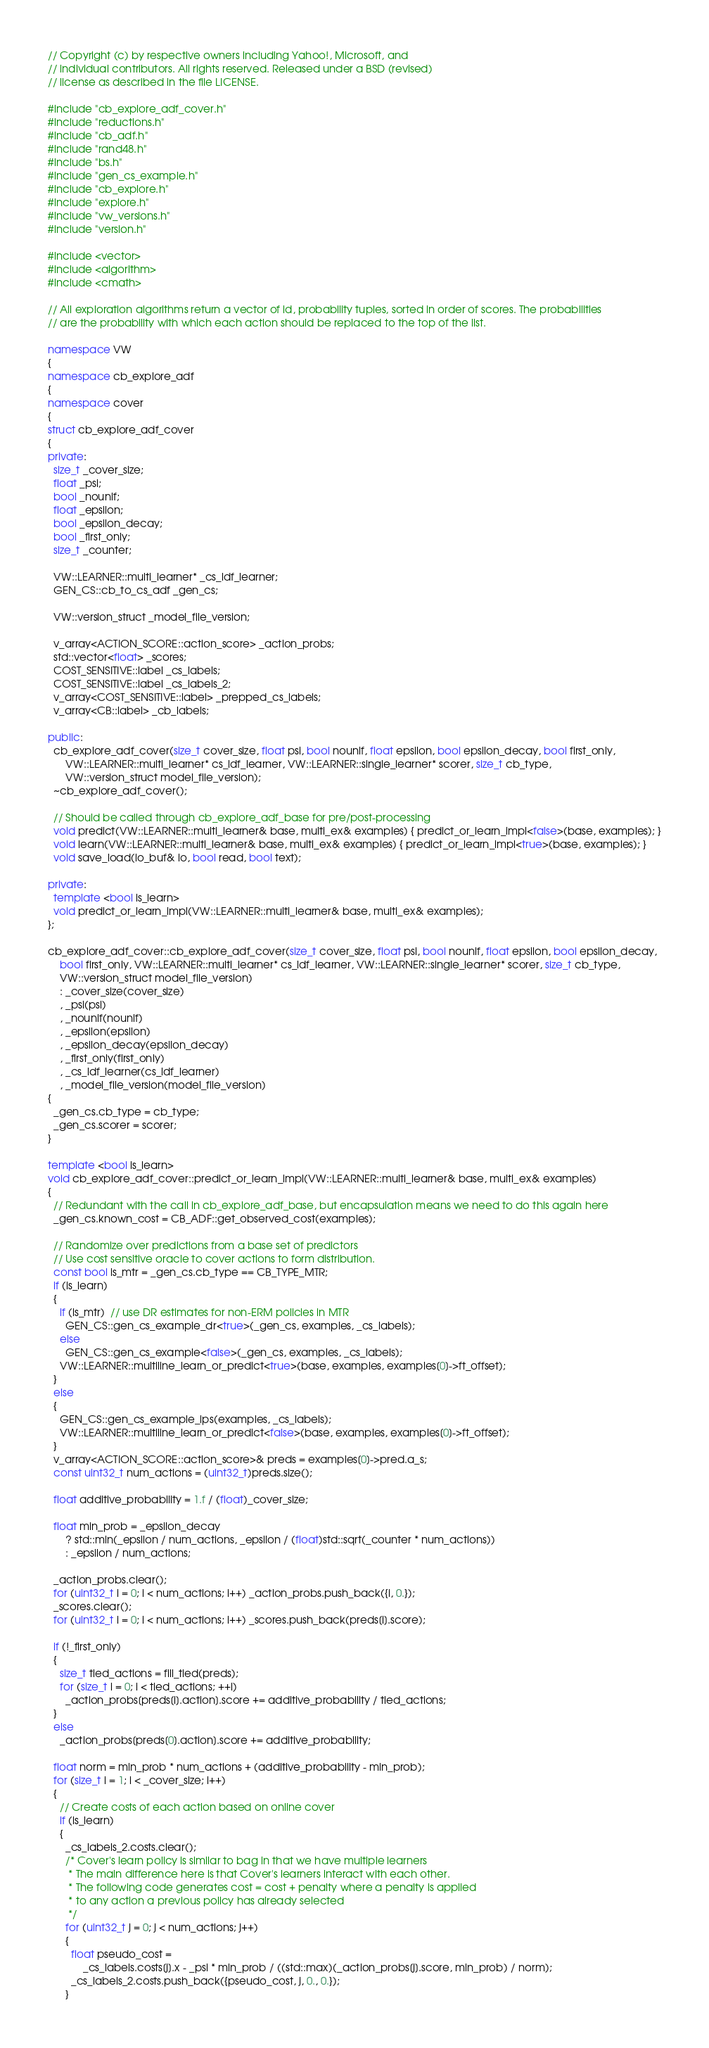Convert code to text. <code><loc_0><loc_0><loc_500><loc_500><_C++_>// Copyright (c) by respective owners including Yahoo!, Microsoft, and
// individual contributors. All rights reserved. Released under a BSD (revised)
// license as described in the file LICENSE.

#include "cb_explore_adf_cover.h"
#include "reductions.h"
#include "cb_adf.h"
#include "rand48.h"
#include "bs.h"
#include "gen_cs_example.h"
#include "cb_explore.h"
#include "explore.h"
#include "vw_versions.h"
#include "version.h"

#include <vector>
#include <algorithm>
#include <cmath>

// All exploration algorithms return a vector of id, probability tuples, sorted in order of scores. The probabilities
// are the probability with which each action should be replaced to the top of the list.

namespace VW
{
namespace cb_explore_adf
{
namespace cover
{
struct cb_explore_adf_cover
{
private:
  size_t _cover_size;
  float _psi;
  bool _nounif;
  float _epsilon;
  bool _epsilon_decay;
  bool _first_only;
  size_t _counter;

  VW::LEARNER::multi_learner* _cs_ldf_learner;
  GEN_CS::cb_to_cs_adf _gen_cs;

  VW::version_struct _model_file_version;

  v_array<ACTION_SCORE::action_score> _action_probs;
  std::vector<float> _scores;
  COST_SENSITIVE::label _cs_labels;
  COST_SENSITIVE::label _cs_labels_2;
  v_array<COST_SENSITIVE::label> _prepped_cs_labels;
  v_array<CB::label> _cb_labels;

public:
  cb_explore_adf_cover(size_t cover_size, float psi, bool nounif, float epsilon, bool epsilon_decay, bool first_only,
      VW::LEARNER::multi_learner* cs_ldf_learner, VW::LEARNER::single_learner* scorer, size_t cb_type,
      VW::version_struct model_file_version);
  ~cb_explore_adf_cover();

  // Should be called through cb_explore_adf_base for pre/post-processing
  void predict(VW::LEARNER::multi_learner& base, multi_ex& examples) { predict_or_learn_impl<false>(base, examples); }
  void learn(VW::LEARNER::multi_learner& base, multi_ex& examples) { predict_or_learn_impl<true>(base, examples); }
  void save_load(io_buf& io, bool read, bool text);

private:
  template <bool is_learn>
  void predict_or_learn_impl(VW::LEARNER::multi_learner& base, multi_ex& examples);
};

cb_explore_adf_cover::cb_explore_adf_cover(size_t cover_size, float psi, bool nounif, float epsilon, bool epsilon_decay,
    bool first_only, VW::LEARNER::multi_learner* cs_ldf_learner, VW::LEARNER::single_learner* scorer, size_t cb_type,
    VW::version_struct model_file_version)
    : _cover_size(cover_size)
    , _psi(psi)
    , _nounif(nounif)
    , _epsilon(epsilon)
    , _epsilon_decay(epsilon_decay)
    , _first_only(first_only)
    , _cs_ldf_learner(cs_ldf_learner)
    , _model_file_version(model_file_version)
{
  _gen_cs.cb_type = cb_type;
  _gen_cs.scorer = scorer;
}

template <bool is_learn>
void cb_explore_adf_cover::predict_or_learn_impl(VW::LEARNER::multi_learner& base, multi_ex& examples)
{
  // Redundant with the call in cb_explore_adf_base, but encapsulation means we need to do this again here
  _gen_cs.known_cost = CB_ADF::get_observed_cost(examples);

  // Randomize over predictions from a base set of predictors
  // Use cost sensitive oracle to cover actions to form distribution.
  const bool is_mtr = _gen_cs.cb_type == CB_TYPE_MTR;
  if (is_learn)
  {
    if (is_mtr)  // use DR estimates for non-ERM policies in MTR
      GEN_CS::gen_cs_example_dr<true>(_gen_cs, examples, _cs_labels);
    else
      GEN_CS::gen_cs_example<false>(_gen_cs, examples, _cs_labels);
    VW::LEARNER::multiline_learn_or_predict<true>(base, examples, examples[0]->ft_offset);
  }
  else
  {
    GEN_CS::gen_cs_example_ips(examples, _cs_labels);
    VW::LEARNER::multiline_learn_or_predict<false>(base, examples, examples[0]->ft_offset);
  }
  v_array<ACTION_SCORE::action_score>& preds = examples[0]->pred.a_s;
  const uint32_t num_actions = (uint32_t)preds.size();

  float additive_probability = 1.f / (float)_cover_size;

  float min_prob = _epsilon_decay
      ? std::min(_epsilon / num_actions, _epsilon / (float)std::sqrt(_counter * num_actions))
      : _epsilon / num_actions;

  _action_probs.clear();
  for (uint32_t i = 0; i < num_actions; i++) _action_probs.push_back({i, 0.});
  _scores.clear();
  for (uint32_t i = 0; i < num_actions; i++) _scores.push_back(preds[i].score);

  if (!_first_only)
  {
    size_t tied_actions = fill_tied(preds);
    for (size_t i = 0; i < tied_actions; ++i)
      _action_probs[preds[i].action].score += additive_probability / tied_actions;
  }
  else
    _action_probs[preds[0].action].score += additive_probability;

  float norm = min_prob * num_actions + (additive_probability - min_prob);
  for (size_t i = 1; i < _cover_size; i++)
  {
    // Create costs of each action based on online cover
    if (is_learn)
    {
      _cs_labels_2.costs.clear();
      /* Cover's learn policy is similar to bag in that we have multiple learners
       * The main difference here is that Cover's learners interact with each other.
       * The following code generates cost = cost + penalty where a penalty is applied
       * to any action a previous policy has already selected
       */
      for (uint32_t j = 0; j < num_actions; j++)
      {
        float pseudo_cost =
            _cs_labels.costs[j].x - _psi * min_prob / ((std::max)(_action_probs[j].score, min_prob) / norm);
        _cs_labels_2.costs.push_back({pseudo_cost, j, 0., 0.});
      }</code> 